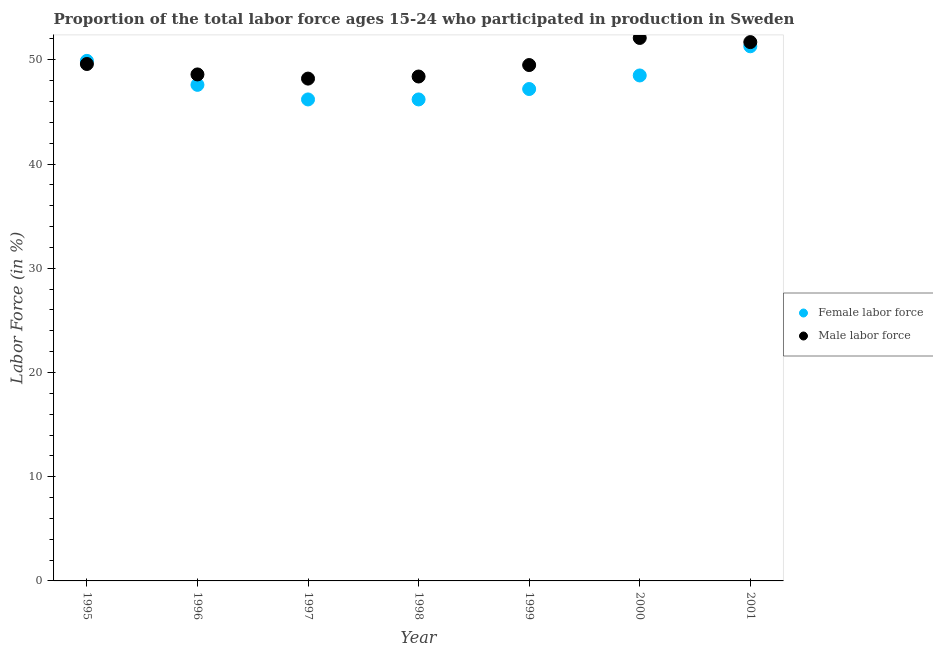How many different coloured dotlines are there?
Give a very brief answer. 2. What is the percentage of male labour force in 1997?
Make the answer very short. 48.2. Across all years, what is the maximum percentage of female labor force?
Provide a short and direct response. 51.3. Across all years, what is the minimum percentage of male labour force?
Your answer should be very brief. 48.2. In which year was the percentage of male labour force maximum?
Ensure brevity in your answer.  2000. What is the total percentage of female labor force in the graph?
Your response must be concise. 336.9. What is the difference between the percentage of male labour force in 1998 and that in 2001?
Provide a short and direct response. -3.3. What is the difference between the percentage of female labor force in 1997 and the percentage of male labour force in 1999?
Your answer should be very brief. -3.3. What is the average percentage of female labor force per year?
Provide a short and direct response. 48.13. In the year 2001, what is the difference between the percentage of male labour force and percentage of female labor force?
Give a very brief answer. 0.4. In how many years, is the percentage of male labour force greater than 4 %?
Provide a short and direct response. 7. What is the ratio of the percentage of female labor force in 1996 to that in 2001?
Provide a succinct answer. 0.93. Is the difference between the percentage of male labour force in 1999 and 2001 greater than the difference between the percentage of female labor force in 1999 and 2001?
Provide a short and direct response. Yes. What is the difference between the highest and the second highest percentage of female labor force?
Keep it short and to the point. 1.4. What is the difference between the highest and the lowest percentage of male labour force?
Your response must be concise. 3.9. In how many years, is the percentage of male labour force greater than the average percentage of male labour force taken over all years?
Your response must be concise. 2. Is the sum of the percentage of male labour force in 1997 and 1999 greater than the maximum percentage of female labor force across all years?
Give a very brief answer. Yes. Does the percentage of male labour force monotonically increase over the years?
Offer a terse response. No. Is the percentage of female labor force strictly greater than the percentage of male labour force over the years?
Give a very brief answer. No. How many dotlines are there?
Provide a short and direct response. 2. How many years are there in the graph?
Your answer should be compact. 7. Are the values on the major ticks of Y-axis written in scientific E-notation?
Provide a succinct answer. No. Does the graph contain any zero values?
Ensure brevity in your answer.  No. Does the graph contain grids?
Your answer should be very brief. No. Where does the legend appear in the graph?
Provide a short and direct response. Center right. How are the legend labels stacked?
Keep it short and to the point. Vertical. What is the title of the graph?
Offer a very short reply. Proportion of the total labor force ages 15-24 who participated in production in Sweden. What is the label or title of the Y-axis?
Make the answer very short. Labor Force (in %). What is the Labor Force (in %) of Female labor force in 1995?
Your answer should be compact. 49.9. What is the Labor Force (in %) in Male labor force in 1995?
Ensure brevity in your answer.  49.6. What is the Labor Force (in %) of Female labor force in 1996?
Offer a terse response. 47.6. What is the Labor Force (in %) of Male labor force in 1996?
Your response must be concise. 48.6. What is the Labor Force (in %) in Female labor force in 1997?
Your response must be concise. 46.2. What is the Labor Force (in %) in Male labor force in 1997?
Offer a terse response. 48.2. What is the Labor Force (in %) of Female labor force in 1998?
Your answer should be very brief. 46.2. What is the Labor Force (in %) in Male labor force in 1998?
Offer a terse response. 48.4. What is the Labor Force (in %) in Female labor force in 1999?
Your response must be concise. 47.2. What is the Labor Force (in %) of Male labor force in 1999?
Your answer should be compact. 49.5. What is the Labor Force (in %) of Female labor force in 2000?
Offer a terse response. 48.5. What is the Labor Force (in %) of Male labor force in 2000?
Offer a terse response. 52.1. What is the Labor Force (in %) of Female labor force in 2001?
Make the answer very short. 51.3. What is the Labor Force (in %) in Male labor force in 2001?
Keep it short and to the point. 51.7. Across all years, what is the maximum Labor Force (in %) of Female labor force?
Your answer should be compact. 51.3. Across all years, what is the maximum Labor Force (in %) of Male labor force?
Your answer should be compact. 52.1. Across all years, what is the minimum Labor Force (in %) of Female labor force?
Provide a short and direct response. 46.2. Across all years, what is the minimum Labor Force (in %) in Male labor force?
Offer a very short reply. 48.2. What is the total Labor Force (in %) in Female labor force in the graph?
Offer a very short reply. 336.9. What is the total Labor Force (in %) in Male labor force in the graph?
Your answer should be very brief. 348.1. What is the difference between the Labor Force (in %) in Female labor force in 1995 and that in 1997?
Your response must be concise. 3.7. What is the difference between the Labor Force (in %) in Female labor force in 1995 and that in 1998?
Your response must be concise. 3.7. What is the difference between the Labor Force (in %) in Female labor force in 1995 and that in 1999?
Keep it short and to the point. 2.7. What is the difference between the Labor Force (in %) in Male labor force in 1995 and that in 1999?
Provide a short and direct response. 0.1. What is the difference between the Labor Force (in %) in Male labor force in 1995 and that in 2001?
Provide a succinct answer. -2.1. What is the difference between the Labor Force (in %) of Female labor force in 1996 and that in 1997?
Provide a succinct answer. 1.4. What is the difference between the Labor Force (in %) in Male labor force in 1996 and that in 1997?
Keep it short and to the point. 0.4. What is the difference between the Labor Force (in %) of Female labor force in 1996 and that in 1998?
Keep it short and to the point. 1.4. What is the difference between the Labor Force (in %) in Male labor force in 1996 and that in 1998?
Provide a short and direct response. 0.2. What is the difference between the Labor Force (in %) in Female labor force in 1996 and that in 1999?
Ensure brevity in your answer.  0.4. What is the difference between the Labor Force (in %) in Male labor force in 1996 and that in 1999?
Ensure brevity in your answer.  -0.9. What is the difference between the Labor Force (in %) in Male labor force in 1996 and that in 2000?
Offer a very short reply. -3.5. What is the difference between the Labor Force (in %) in Female labor force in 1996 and that in 2001?
Ensure brevity in your answer.  -3.7. What is the difference between the Labor Force (in %) in Female labor force in 1997 and that in 2000?
Make the answer very short. -2.3. What is the difference between the Labor Force (in %) of Female labor force in 1997 and that in 2001?
Make the answer very short. -5.1. What is the difference between the Labor Force (in %) of Female labor force in 1998 and that in 1999?
Keep it short and to the point. -1. What is the difference between the Labor Force (in %) of Female labor force in 1998 and that in 2000?
Give a very brief answer. -2.3. What is the difference between the Labor Force (in %) of Male labor force in 1998 and that in 2000?
Make the answer very short. -3.7. What is the difference between the Labor Force (in %) in Female labor force in 1998 and that in 2001?
Provide a short and direct response. -5.1. What is the difference between the Labor Force (in %) in Male labor force in 1998 and that in 2001?
Provide a short and direct response. -3.3. What is the difference between the Labor Force (in %) in Male labor force in 1999 and that in 2000?
Your response must be concise. -2.6. What is the difference between the Labor Force (in %) in Female labor force in 1999 and that in 2001?
Keep it short and to the point. -4.1. What is the difference between the Labor Force (in %) of Female labor force in 1995 and the Labor Force (in %) of Male labor force in 1996?
Ensure brevity in your answer.  1.3. What is the difference between the Labor Force (in %) of Female labor force in 1995 and the Labor Force (in %) of Male labor force in 1997?
Make the answer very short. 1.7. What is the difference between the Labor Force (in %) of Female labor force in 1995 and the Labor Force (in %) of Male labor force in 2000?
Give a very brief answer. -2.2. What is the difference between the Labor Force (in %) of Female labor force in 1995 and the Labor Force (in %) of Male labor force in 2001?
Offer a very short reply. -1.8. What is the difference between the Labor Force (in %) in Female labor force in 1996 and the Labor Force (in %) in Male labor force in 1999?
Offer a terse response. -1.9. What is the difference between the Labor Force (in %) in Female labor force in 1997 and the Labor Force (in %) in Male labor force in 1998?
Ensure brevity in your answer.  -2.2. What is the difference between the Labor Force (in %) of Female labor force in 1997 and the Labor Force (in %) of Male labor force in 1999?
Provide a succinct answer. -3.3. What is the difference between the Labor Force (in %) in Female labor force in 1997 and the Labor Force (in %) in Male labor force in 2000?
Make the answer very short. -5.9. What is the difference between the Labor Force (in %) of Female labor force in 1997 and the Labor Force (in %) of Male labor force in 2001?
Give a very brief answer. -5.5. What is the difference between the Labor Force (in %) in Female labor force in 1998 and the Labor Force (in %) in Male labor force in 2000?
Make the answer very short. -5.9. What is the difference between the Labor Force (in %) of Female labor force in 1998 and the Labor Force (in %) of Male labor force in 2001?
Your answer should be compact. -5.5. What is the difference between the Labor Force (in %) in Female labor force in 1999 and the Labor Force (in %) in Male labor force in 2001?
Ensure brevity in your answer.  -4.5. What is the average Labor Force (in %) of Female labor force per year?
Give a very brief answer. 48.13. What is the average Labor Force (in %) in Male labor force per year?
Your response must be concise. 49.73. In the year 1996, what is the difference between the Labor Force (in %) of Female labor force and Labor Force (in %) of Male labor force?
Give a very brief answer. -1. In the year 1999, what is the difference between the Labor Force (in %) in Female labor force and Labor Force (in %) in Male labor force?
Ensure brevity in your answer.  -2.3. What is the ratio of the Labor Force (in %) in Female labor force in 1995 to that in 1996?
Provide a short and direct response. 1.05. What is the ratio of the Labor Force (in %) in Male labor force in 1995 to that in 1996?
Give a very brief answer. 1.02. What is the ratio of the Labor Force (in %) of Female labor force in 1995 to that in 1997?
Provide a short and direct response. 1.08. What is the ratio of the Labor Force (in %) of Female labor force in 1995 to that in 1998?
Your answer should be very brief. 1.08. What is the ratio of the Labor Force (in %) of Male labor force in 1995 to that in 1998?
Your response must be concise. 1.02. What is the ratio of the Labor Force (in %) of Female labor force in 1995 to that in 1999?
Give a very brief answer. 1.06. What is the ratio of the Labor Force (in %) in Male labor force in 1995 to that in 1999?
Provide a succinct answer. 1. What is the ratio of the Labor Force (in %) in Female labor force in 1995 to that in 2000?
Provide a succinct answer. 1.03. What is the ratio of the Labor Force (in %) of Male labor force in 1995 to that in 2000?
Keep it short and to the point. 0.95. What is the ratio of the Labor Force (in %) in Female labor force in 1995 to that in 2001?
Make the answer very short. 0.97. What is the ratio of the Labor Force (in %) of Male labor force in 1995 to that in 2001?
Offer a very short reply. 0.96. What is the ratio of the Labor Force (in %) of Female labor force in 1996 to that in 1997?
Provide a succinct answer. 1.03. What is the ratio of the Labor Force (in %) of Male labor force in 1996 to that in 1997?
Provide a short and direct response. 1.01. What is the ratio of the Labor Force (in %) of Female labor force in 1996 to that in 1998?
Give a very brief answer. 1.03. What is the ratio of the Labor Force (in %) of Male labor force in 1996 to that in 1998?
Give a very brief answer. 1. What is the ratio of the Labor Force (in %) in Female labor force in 1996 to that in 1999?
Offer a very short reply. 1.01. What is the ratio of the Labor Force (in %) in Male labor force in 1996 to that in 1999?
Offer a terse response. 0.98. What is the ratio of the Labor Force (in %) of Female labor force in 1996 to that in 2000?
Your answer should be very brief. 0.98. What is the ratio of the Labor Force (in %) of Male labor force in 1996 to that in 2000?
Offer a very short reply. 0.93. What is the ratio of the Labor Force (in %) in Female labor force in 1996 to that in 2001?
Make the answer very short. 0.93. What is the ratio of the Labor Force (in %) of Female labor force in 1997 to that in 1998?
Offer a terse response. 1. What is the ratio of the Labor Force (in %) in Male labor force in 1997 to that in 1998?
Ensure brevity in your answer.  1. What is the ratio of the Labor Force (in %) of Female labor force in 1997 to that in 1999?
Make the answer very short. 0.98. What is the ratio of the Labor Force (in %) of Male labor force in 1997 to that in 1999?
Make the answer very short. 0.97. What is the ratio of the Labor Force (in %) of Female labor force in 1997 to that in 2000?
Offer a terse response. 0.95. What is the ratio of the Labor Force (in %) of Male labor force in 1997 to that in 2000?
Provide a succinct answer. 0.93. What is the ratio of the Labor Force (in %) of Female labor force in 1997 to that in 2001?
Your answer should be very brief. 0.9. What is the ratio of the Labor Force (in %) in Male labor force in 1997 to that in 2001?
Provide a succinct answer. 0.93. What is the ratio of the Labor Force (in %) in Female labor force in 1998 to that in 1999?
Provide a succinct answer. 0.98. What is the ratio of the Labor Force (in %) of Male labor force in 1998 to that in 1999?
Your response must be concise. 0.98. What is the ratio of the Labor Force (in %) of Female labor force in 1998 to that in 2000?
Offer a terse response. 0.95. What is the ratio of the Labor Force (in %) in Male labor force in 1998 to that in 2000?
Keep it short and to the point. 0.93. What is the ratio of the Labor Force (in %) of Female labor force in 1998 to that in 2001?
Give a very brief answer. 0.9. What is the ratio of the Labor Force (in %) in Male labor force in 1998 to that in 2001?
Offer a very short reply. 0.94. What is the ratio of the Labor Force (in %) of Female labor force in 1999 to that in 2000?
Offer a terse response. 0.97. What is the ratio of the Labor Force (in %) of Male labor force in 1999 to that in 2000?
Make the answer very short. 0.95. What is the ratio of the Labor Force (in %) in Female labor force in 1999 to that in 2001?
Your response must be concise. 0.92. What is the ratio of the Labor Force (in %) in Male labor force in 1999 to that in 2001?
Offer a very short reply. 0.96. What is the ratio of the Labor Force (in %) in Female labor force in 2000 to that in 2001?
Ensure brevity in your answer.  0.95. What is the ratio of the Labor Force (in %) in Male labor force in 2000 to that in 2001?
Keep it short and to the point. 1.01. What is the difference between the highest and the second highest Labor Force (in %) in Male labor force?
Offer a very short reply. 0.4. What is the difference between the highest and the lowest Labor Force (in %) in Male labor force?
Provide a succinct answer. 3.9. 